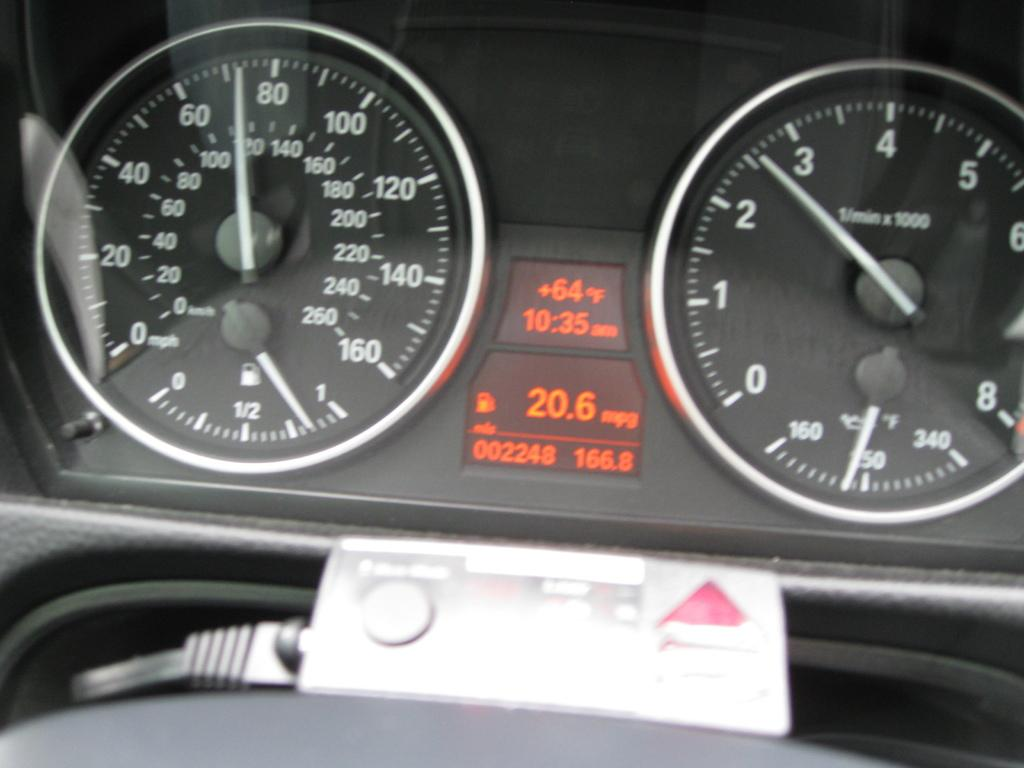What type of instrument can be found on the dashboard of the car in the image? There are speedometers present on the dashboard of the car in the image. What type of hobbies can be seen in the image? There are no hobbies visible in the image; it features a car with speedometers on the dashboard. Where is the quiver located in the image? There is no quiver present in the image. 